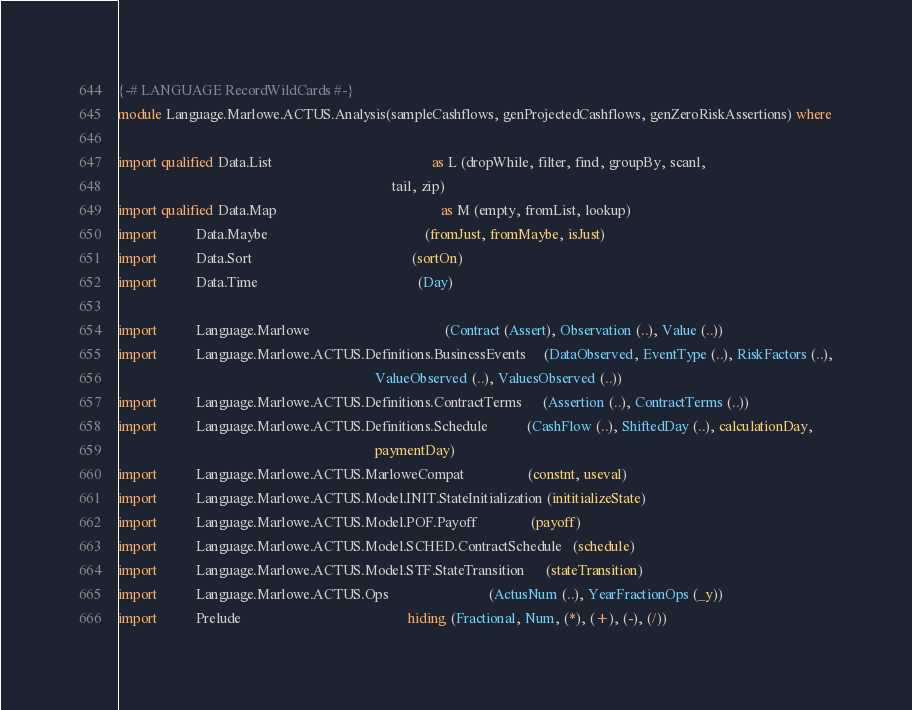Convert code to text. <code><loc_0><loc_0><loc_500><loc_500><_Haskell_>{-# LANGUAGE RecordWildCards #-}
module Language.Marlowe.ACTUS.Analysis(sampleCashflows, genProjectedCashflows, genZeroRiskAssertions) where

import qualified Data.List                                             as L (dropWhile, filter, find, groupBy, scanl,
                                                                             tail, zip)
import qualified Data.Map                                              as M (empty, fromList, lookup)
import           Data.Maybe                                            (fromJust, fromMaybe, isJust)
import           Data.Sort                                             (sortOn)
import           Data.Time                                             (Day)

import           Language.Marlowe                                      (Contract (Assert), Observation (..), Value (..))
import           Language.Marlowe.ACTUS.Definitions.BusinessEvents     (DataObserved, EventType (..), RiskFactors (..),
                                                                        ValueObserved (..), ValuesObserved (..))
import           Language.Marlowe.ACTUS.Definitions.ContractTerms      (Assertion (..), ContractTerms (..))
import           Language.Marlowe.ACTUS.Definitions.Schedule           (CashFlow (..), ShiftedDay (..), calculationDay,
                                                                        paymentDay)
import           Language.Marlowe.ACTUS.MarloweCompat                  (constnt, useval)
import           Language.Marlowe.ACTUS.Model.INIT.StateInitialization (inititializeState)
import           Language.Marlowe.ACTUS.Model.POF.Payoff               (payoff)
import           Language.Marlowe.ACTUS.Model.SCHED.ContractSchedule   (schedule)
import           Language.Marlowe.ACTUS.Model.STF.StateTransition      (stateTransition)
import           Language.Marlowe.ACTUS.Ops                            (ActusNum (..), YearFractionOps (_y))
import           Prelude                                               hiding (Fractional, Num, (*), (+), (-), (/))

</code> 